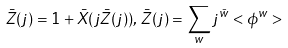Convert formula to latex. <formula><loc_0><loc_0><loc_500><loc_500>\bar { Z } ( j ) = 1 + \bar { X } ( j \bar { Z } ( j ) ) , \, \bar { Z } ( j ) = \sum _ { w } j ^ { \bar { w } } < \phi ^ { w } ></formula> 